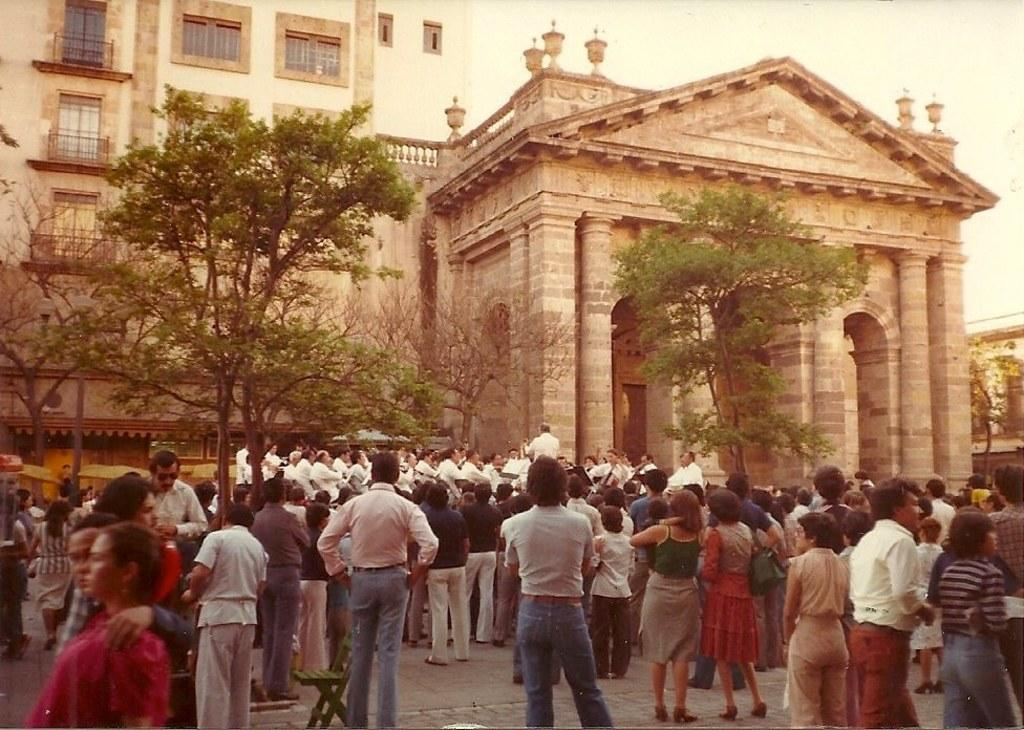What are the people in the foreground of the image doing? The people in the foreground of the image are standing and walking. What object can be seen in the image that is typically used for sitting? There is a chair in the image. What type of vegetation is present in the image? There are trees in the image. What type of structures can be seen in the image? There are buildings in the image. What is visible in the background of the image? The sky is visible in the image. Why are the people in the image crying and using a whip? There is no indication in the image that the people are crying or using a whip; they are simply standing and walking. 